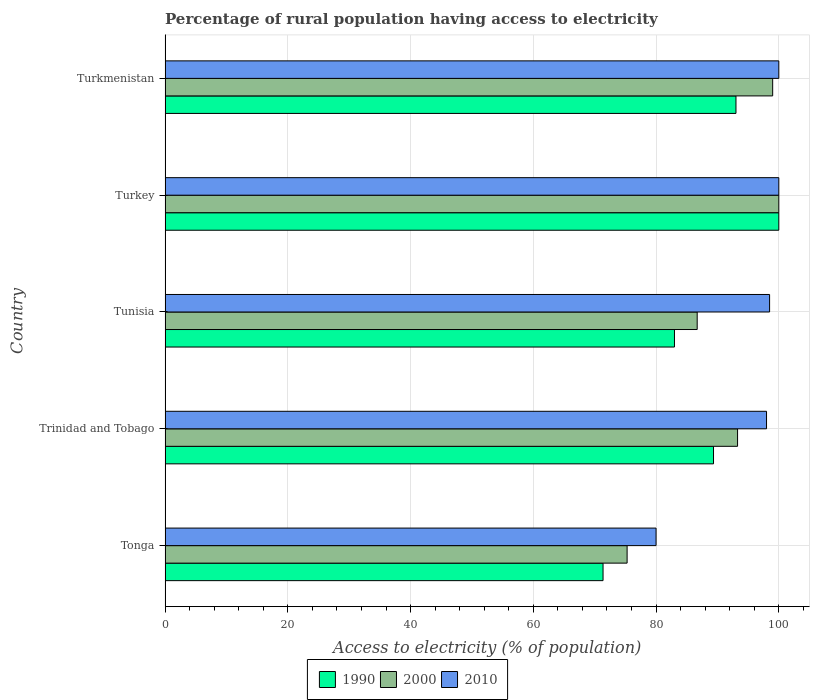How many groups of bars are there?
Provide a short and direct response. 5. Are the number of bars per tick equal to the number of legend labels?
Provide a succinct answer. Yes. How many bars are there on the 3rd tick from the top?
Ensure brevity in your answer.  3. What is the label of the 1st group of bars from the top?
Provide a succinct answer. Turkmenistan. In how many cases, is the number of bars for a given country not equal to the number of legend labels?
Offer a very short reply. 0. What is the percentage of rural population having access to electricity in 1990 in Tonga?
Ensure brevity in your answer.  71.36. Across all countries, what is the maximum percentage of rural population having access to electricity in 2000?
Provide a succinct answer. 100. Across all countries, what is the minimum percentage of rural population having access to electricity in 2000?
Offer a very short reply. 75.28. In which country was the percentage of rural population having access to electricity in 1990 maximum?
Your answer should be compact. Turkey. In which country was the percentage of rural population having access to electricity in 2000 minimum?
Your response must be concise. Tonga. What is the total percentage of rural population having access to electricity in 1990 in the graph?
Your answer should be compact. 436.74. What is the difference between the percentage of rural population having access to electricity in 2010 in Trinidad and Tobago and the percentage of rural population having access to electricity in 2000 in Turkey?
Provide a short and direct response. -2. What is the average percentage of rural population having access to electricity in 2000 per country?
Provide a short and direct response. 90.85. What is the difference between the percentage of rural population having access to electricity in 2000 and percentage of rural population having access to electricity in 2010 in Tonga?
Offer a very short reply. -4.72. What is the ratio of the percentage of rural population having access to electricity in 2010 in Trinidad and Tobago to that in Turkmenistan?
Your answer should be compact. 0.98. Is the difference between the percentage of rural population having access to electricity in 2000 in Turkey and Turkmenistan greater than the difference between the percentage of rural population having access to electricity in 2010 in Turkey and Turkmenistan?
Provide a short and direct response. Yes. What is the difference between the highest and the second highest percentage of rural population having access to electricity in 1990?
Ensure brevity in your answer.  6.98. What is the difference between the highest and the lowest percentage of rural population having access to electricity in 2000?
Give a very brief answer. 24.72. What does the 2nd bar from the top in Turkmenistan represents?
Give a very brief answer. 2000. What does the 2nd bar from the bottom in Trinidad and Tobago represents?
Make the answer very short. 2000. Are all the bars in the graph horizontal?
Provide a succinct answer. Yes. How many countries are there in the graph?
Offer a terse response. 5. Does the graph contain grids?
Offer a very short reply. Yes. Where does the legend appear in the graph?
Offer a terse response. Bottom center. What is the title of the graph?
Provide a succinct answer. Percentage of rural population having access to electricity. Does "1966" appear as one of the legend labels in the graph?
Keep it short and to the point. No. What is the label or title of the X-axis?
Your response must be concise. Access to electricity (% of population). What is the Access to electricity (% of population) in 1990 in Tonga?
Your response must be concise. 71.36. What is the Access to electricity (% of population) of 2000 in Tonga?
Give a very brief answer. 75.28. What is the Access to electricity (% of population) of 1990 in Trinidad and Tobago?
Keep it short and to the point. 89.36. What is the Access to electricity (% of population) in 2000 in Trinidad and Tobago?
Keep it short and to the point. 93.28. What is the Access to electricity (% of population) of 2010 in Trinidad and Tobago?
Keep it short and to the point. 98. What is the Access to electricity (% of population) of 2000 in Tunisia?
Ensure brevity in your answer.  86.7. What is the Access to electricity (% of population) of 2010 in Tunisia?
Offer a very short reply. 98.5. What is the Access to electricity (% of population) of 1990 in Turkey?
Give a very brief answer. 100. What is the Access to electricity (% of population) in 2000 in Turkey?
Keep it short and to the point. 100. What is the Access to electricity (% of population) of 2010 in Turkey?
Give a very brief answer. 100. What is the Access to electricity (% of population) in 1990 in Turkmenistan?
Offer a terse response. 93.02. Across all countries, what is the maximum Access to electricity (% of population) in 1990?
Offer a very short reply. 100. Across all countries, what is the maximum Access to electricity (% of population) of 2010?
Provide a succinct answer. 100. Across all countries, what is the minimum Access to electricity (% of population) of 1990?
Offer a very short reply. 71.36. Across all countries, what is the minimum Access to electricity (% of population) in 2000?
Offer a terse response. 75.28. Across all countries, what is the minimum Access to electricity (% of population) of 2010?
Your answer should be very brief. 80. What is the total Access to electricity (% of population) in 1990 in the graph?
Provide a short and direct response. 436.74. What is the total Access to electricity (% of population) in 2000 in the graph?
Your answer should be compact. 454.26. What is the total Access to electricity (% of population) of 2010 in the graph?
Make the answer very short. 476.5. What is the difference between the Access to electricity (% of population) in 2000 in Tonga and that in Trinidad and Tobago?
Give a very brief answer. -18. What is the difference between the Access to electricity (% of population) of 1990 in Tonga and that in Tunisia?
Your response must be concise. -11.64. What is the difference between the Access to electricity (% of population) in 2000 in Tonga and that in Tunisia?
Keep it short and to the point. -11.42. What is the difference between the Access to electricity (% of population) in 2010 in Tonga and that in Tunisia?
Provide a short and direct response. -18.5. What is the difference between the Access to electricity (% of population) in 1990 in Tonga and that in Turkey?
Ensure brevity in your answer.  -28.64. What is the difference between the Access to electricity (% of population) of 2000 in Tonga and that in Turkey?
Provide a short and direct response. -24.72. What is the difference between the Access to electricity (% of population) in 2010 in Tonga and that in Turkey?
Your response must be concise. -20. What is the difference between the Access to electricity (% of population) in 1990 in Tonga and that in Turkmenistan?
Offer a very short reply. -21.66. What is the difference between the Access to electricity (% of population) in 2000 in Tonga and that in Turkmenistan?
Ensure brevity in your answer.  -23.72. What is the difference between the Access to electricity (% of population) in 2010 in Tonga and that in Turkmenistan?
Make the answer very short. -20. What is the difference between the Access to electricity (% of population) in 1990 in Trinidad and Tobago and that in Tunisia?
Make the answer very short. 6.36. What is the difference between the Access to electricity (% of population) of 2000 in Trinidad and Tobago and that in Tunisia?
Ensure brevity in your answer.  6.58. What is the difference between the Access to electricity (% of population) of 1990 in Trinidad and Tobago and that in Turkey?
Offer a terse response. -10.64. What is the difference between the Access to electricity (% of population) of 2000 in Trinidad and Tobago and that in Turkey?
Your response must be concise. -6.72. What is the difference between the Access to electricity (% of population) in 2010 in Trinidad and Tobago and that in Turkey?
Your answer should be compact. -2. What is the difference between the Access to electricity (% of population) in 1990 in Trinidad and Tobago and that in Turkmenistan?
Provide a short and direct response. -3.66. What is the difference between the Access to electricity (% of population) in 2000 in Trinidad and Tobago and that in Turkmenistan?
Ensure brevity in your answer.  -5.72. What is the difference between the Access to electricity (% of population) in 1990 in Tunisia and that in Turkey?
Offer a terse response. -17. What is the difference between the Access to electricity (% of population) in 1990 in Tunisia and that in Turkmenistan?
Ensure brevity in your answer.  -10.02. What is the difference between the Access to electricity (% of population) in 2000 in Tunisia and that in Turkmenistan?
Make the answer very short. -12.3. What is the difference between the Access to electricity (% of population) in 1990 in Turkey and that in Turkmenistan?
Give a very brief answer. 6.98. What is the difference between the Access to electricity (% of population) of 2010 in Turkey and that in Turkmenistan?
Offer a terse response. 0. What is the difference between the Access to electricity (% of population) of 1990 in Tonga and the Access to electricity (% of population) of 2000 in Trinidad and Tobago?
Your response must be concise. -21.92. What is the difference between the Access to electricity (% of population) of 1990 in Tonga and the Access to electricity (% of population) of 2010 in Trinidad and Tobago?
Your response must be concise. -26.64. What is the difference between the Access to electricity (% of population) of 2000 in Tonga and the Access to electricity (% of population) of 2010 in Trinidad and Tobago?
Ensure brevity in your answer.  -22.72. What is the difference between the Access to electricity (% of population) of 1990 in Tonga and the Access to electricity (% of population) of 2000 in Tunisia?
Ensure brevity in your answer.  -15.34. What is the difference between the Access to electricity (% of population) of 1990 in Tonga and the Access to electricity (% of population) of 2010 in Tunisia?
Your answer should be very brief. -27.14. What is the difference between the Access to electricity (% of population) of 2000 in Tonga and the Access to electricity (% of population) of 2010 in Tunisia?
Your response must be concise. -23.22. What is the difference between the Access to electricity (% of population) in 1990 in Tonga and the Access to electricity (% of population) in 2000 in Turkey?
Provide a succinct answer. -28.64. What is the difference between the Access to electricity (% of population) in 1990 in Tonga and the Access to electricity (% of population) in 2010 in Turkey?
Your answer should be compact. -28.64. What is the difference between the Access to electricity (% of population) of 2000 in Tonga and the Access to electricity (% of population) of 2010 in Turkey?
Your response must be concise. -24.72. What is the difference between the Access to electricity (% of population) of 1990 in Tonga and the Access to electricity (% of population) of 2000 in Turkmenistan?
Ensure brevity in your answer.  -27.64. What is the difference between the Access to electricity (% of population) in 1990 in Tonga and the Access to electricity (% of population) in 2010 in Turkmenistan?
Offer a very short reply. -28.64. What is the difference between the Access to electricity (% of population) of 2000 in Tonga and the Access to electricity (% of population) of 2010 in Turkmenistan?
Your answer should be compact. -24.72. What is the difference between the Access to electricity (% of population) in 1990 in Trinidad and Tobago and the Access to electricity (% of population) in 2000 in Tunisia?
Offer a very short reply. 2.66. What is the difference between the Access to electricity (% of population) of 1990 in Trinidad and Tobago and the Access to electricity (% of population) of 2010 in Tunisia?
Offer a terse response. -9.14. What is the difference between the Access to electricity (% of population) in 2000 in Trinidad and Tobago and the Access to electricity (% of population) in 2010 in Tunisia?
Provide a short and direct response. -5.22. What is the difference between the Access to electricity (% of population) in 1990 in Trinidad and Tobago and the Access to electricity (% of population) in 2000 in Turkey?
Your answer should be very brief. -10.64. What is the difference between the Access to electricity (% of population) in 1990 in Trinidad and Tobago and the Access to electricity (% of population) in 2010 in Turkey?
Give a very brief answer. -10.64. What is the difference between the Access to electricity (% of population) of 2000 in Trinidad and Tobago and the Access to electricity (% of population) of 2010 in Turkey?
Offer a very short reply. -6.72. What is the difference between the Access to electricity (% of population) of 1990 in Trinidad and Tobago and the Access to electricity (% of population) of 2000 in Turkmenistan?
Give a very brief answer. -9.64. What is the difference between the Access to electricity (% of population) in 1990 in Trinidad and Tobago and the Access to electricity (% of population) in 2010 in Turkmenistan?
Your answer should be compact. -10.64. What is the difference between the Access to electricity (% of population) in 2000 in Trinidad and Tobago and the Access to electricity (% of population) in 2010 in Turkmenistan?
Keep it short and to the point. -6.72. What is the difference between the Access to electricity (% of population) in 1990 in Tunisia and the Access to electricity (% of population) in 2010 in Turkey?
Make the answer very short. -17. What is the difference between the Access to electricity (% of population) of 1990 in Tunisia and the Access to electricity (% of population) of 2000 in Turkmenistan?
Offer a terse response. -16. What is the difference between the Access to electricity (% of population) of 1990 in Tunisia and the Access to electricity (% of population) of 2010 in Turkmenistan?
Make the answer very short. -17. What is the difference between the Access to electricity (% of population) of 2000 in Tunisia and the Access to electricity (% of population) of 2010 in Turkmenistan?
Your answer should be very brief. -13.3. What is the difference between the Access to electricity (% of population) of 1990 in Turkey and the Access to electricity (% of population) of 2000 in Turkmenistan?
Your response must be concise. 1. What is the difference between the Access to electricity (% of population) of 1990 in Turkey and the Access to electricity (% of population) of 2010 in Turkmenistan?
Ensure brevity in your answer.  0. What is the average Access to electricity (% of population) of 1990 per country?
Give a very brief answer. 87.35. What is the average Access to electricity (% of population) in 2000 per country?
Make the answer very short. 90.85. What is the average Access to electricity (% of population) in 2010 per country?
Your answer should be very brief. 95.3. What is the difference between the Access to electricity (% of population) in 1990 and Access to electricity (% of population) in 2000 in Tonga?
Make the answer very short. -3.92. What is the difference between the Access to electricity (% of population) in 1990 and Access to electricity (% of population) in 2010 in Tonga?
Your response must be concise. -8.64. What is the difference between the Access to electricity (% of population) of 2000 and Access to electricity (% of population) of 2010 in Tonga?
Your answer should be compact. -4.72. What is the difference between the Access to electricity (% of population) of 1990 and Access to electricity (% of population) of 2000 in Trinidad and Tobago?
Your answer should be compact. -3.92. What is the difference between the Access to electricity (% of population) of 1990 and Access to electricity (% of population) of 2010 in Trinidad and Tobago?
Give a very brief answer. -8.64. What is the difference between the Access to electricity (% of population) of 2000 and Access to electricity (% of population) of 2010 in Trinidad and Tobago?
Offer a terse response. -4.72. What is the difference between the Access to electricity (% of population) of 1990 and Access to electricity (% of population) of 2010 in Tunisia?
Provide a short and direct response. -15.5. What is the difference between the Access to electricity (% of population) of 2000 and Access to electricity (% of population) of 2010 in Tunisia?
Offer a terse response. -11.8. What is the difference between the Access to electricity (% of population) of 1990 and Access to electricity (% of population) of 2000 in Turkey?
Your response must be concise. 0. What is the difference between the Access to electricity (% of population) of 2000 and Access to electricity (% of population) of 2010 in Turkey?
Offer a terse response. 0. What is the difference between the Access to electricity (% of population) in 1990 and Access to electricity (% of population) in 2000 in Turkmenistan?
Your answer should be very brief. -5.98. What is the difference between the Access to electricity (% of population) in 1990 and Access to electricity (% of population) in 2010 in Turkmenistan?
Provide a short and direct response. -6.98. What is the ratio of the Access to electricity (% of population) in 1990 in Tonga to that in Trinidad and Tobago?
Ensure brevity in your answer.  0.8. What is the ratio of the Access to electricity (% of population) of 2000 in Tonga to that in Trinidad and Tobago?
Offer a terse response. 0.81. What is the ratio of the Access to electricity (% of population) of 2010 in Tonga to that in Trinidad and Tobago?
Offer a very short reply. 0.82. What is the ratio of the Access to electricity (% of population) of 1990 in Tonga to that in Tunisia?
Your answer should be very brief. 0.86. What is the ratio of the Access to electricity (% of population) in 2000 in Tonga to that in Tunisia?
Your response must be concise. 0.87. What is the ratio of the Access to electricity (% of population) in 2010 in Tonga to that in Tunisia?
Keep it short and to the point. 0.81. What is the ratio of the Access to electricity (% of population) of 1990 in Tonga to that in Turkey?
Ensure brevity in your answer.  0.71. What is the ratio of the Access to electricity (% of population) in 2000 in Tonga to that in Turkey?
Provide a succinct answer. 0.75. What is the ratio of the Access to electricity (% of population) of 2010 in Tonga to that in Turkey?
Keep it short and to the point. 0.8. What is the ratio of the Access to electricity (% of population) in 1990 in Tonga to that in Turkmenistan?
Make the answer very short. 0.77. What is the ratio of the Access to electricity (% of population) in 2000 in Tonga to that in Turkmenistan?
Ensure brevity in your answer.  0.76. What is the ratio of the Access to electricity (% of population) of 2010 in Tonga to that in Turkmenistan?
Keep it short and to the point. 0.8. What is the ratio of the Access to electricity (% of population) of 1990 in Trinidad and Tobago to that in Tunisia?
Ensure brevity in your answer.  1.08. What is the ratio of the Access to electricity (% of population) of 2000 in Trinidad and Tobago to that in Tunisia?
Provide a succinct answer. 1.08. What is the ratio of the Access to electricity (% of population) in 2010 in Trinidad and Tobago to that in Tunisia?
Offer a very short reply. 0.99. What is the ratio of the Access to electricity (% of population) in 1990 in Trinidad and Tobago to that in Turkey?
Offer a very short reply. 0.89. What is the ratio of the Access to electricity (% of population) in 2000 in Trinidad and Tobago to that in Turkey?
Provide a short and direct response. 0.93. What is the ratio of the Access to electricity (% of population) of 2010 in Trinidad and Tobago to that in Turkey?
Your answer should be compact. 0.98. What is the ratio of the Access to electricity (% of population) of 1990 in Trinidad and Tobago to that in Turkmenistan?
Provide a succinct answer. 0.96. What is the ratio of the Access to electricity (% of population) of 2000 in Trinidad and Tobago to that in Turkmenistan?
Offer a terse response. 0.94. What is the ratio of the Access to electricity (% of population) of 2010 in Trinidad and Tobago to that in Turkmenistan?
Provide a short and direct response. 0.98. What is the ratio of the Access to electricity (% of population) in 1990 in Tunisia to that in Turkey?
Your response must be concise. 0.83. What is the ratio of the Access to electricity (% of population) of 2000 in Tunisia to that in Turkey?
Make the answer very short. 0.87. What is the ratio of the Access to electricity (% of population) in 2010 in Tunisia to that in Turkey?
Offer a terse response. 0.98. What is the ratio of the Access to electricity (% of population) of 1990 in Tunisia to that in Turkmenistan?
Give a very brief answer. 0.89. What is the ratio of the Access to electricity (% of population) of 2000 in Tunisia to that in Turkmenistan?
Offer a very short reply. 0.88. What is the ratio of the Access to electricity (% of population) of 1990 in Turkey to that in Turkmenistan?
Your answer should be compact. 1.07. What is the ratio of the Access to electricity (% of population) of 2000 in Turkey to that in Turkmenistan?
Offer a very short reply. 1.01. What is the ratio of the Access to electricity (% of population) of 2010 in Turkey to that in Turkmenistan?
Your answer should be very brief. 1. What is the difference between the highest and the second highest Access to electricity (% of population) in 1990?
Keep it short and to the point. 6.98. What is the difference between the highest and the second highest Access to electricity (% of population) of 2010?
Give a very brief answer. 0. What is the difference between the highest and the lowest Access to electricity (% of population) of 1990?
Keep it short and to the point. 28.64. What is the difference between the highest and the lowest Access to electricity (% of population) of 2000?
Ensure brevity in your answer.  24.72. What is the difference between the highest and the lowest Access to electricity (% of population) of 2010?
Give a very brief answer. 20. 